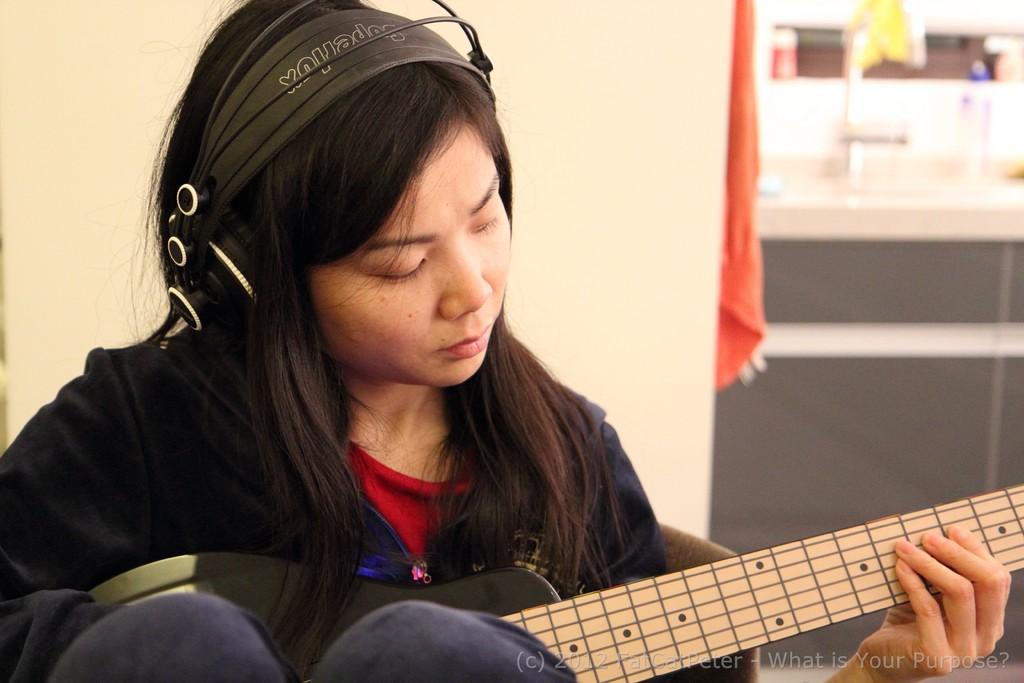Who is the main subject in the image? There is a woman in the image. What is the woman doing in the image? The woman is playing a guitar. What is the woman wearing in the image? The woman is wearing a headset. What is the woman sitting on in the image? The woman is sitting in a chair. What type of sail can be seen in the image? There is no sail present in the image. Who is the judge in the image? There is no judge present in the image. 